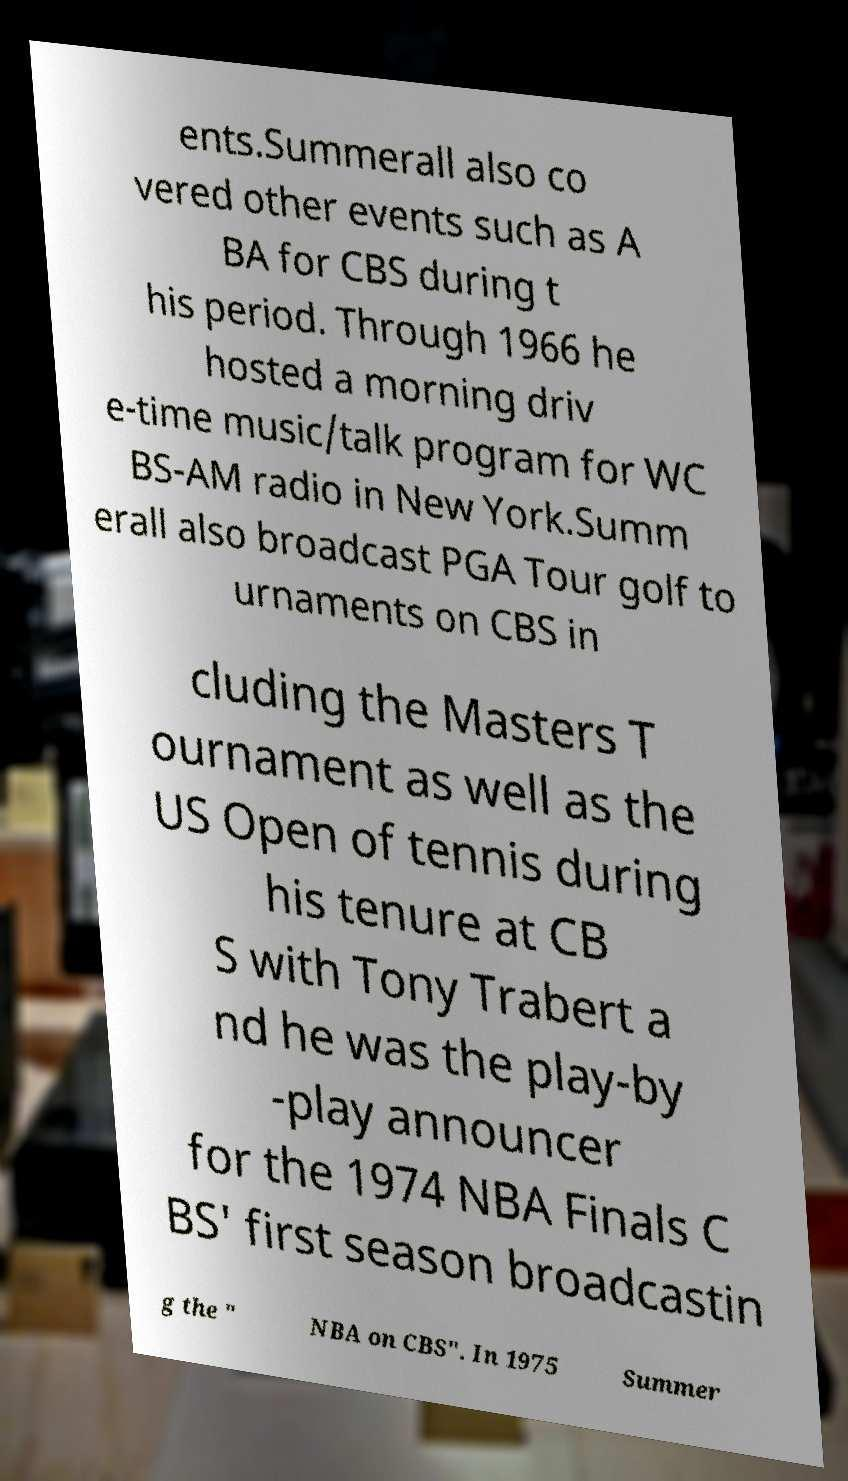Can you accurately transcribe the text from the provided image for me? ents.Summerall also co vered other events such as A BA for CBS during t his period. Through 1966 he hosted a morning driv e-time music/talk program for WC BS-AM radio in New York.Summ erall also broadcast PGA Tour golf to urnaments on CBS in cluding the Masters T ournament as well as the US Open of tennis during his tenure at CB S with Tony Trabert a nd he was the play-by -play announcer for the 1974 NBA Finals C BS' first season broadcastin g the " NBA on CBS". In 1975 Summer 